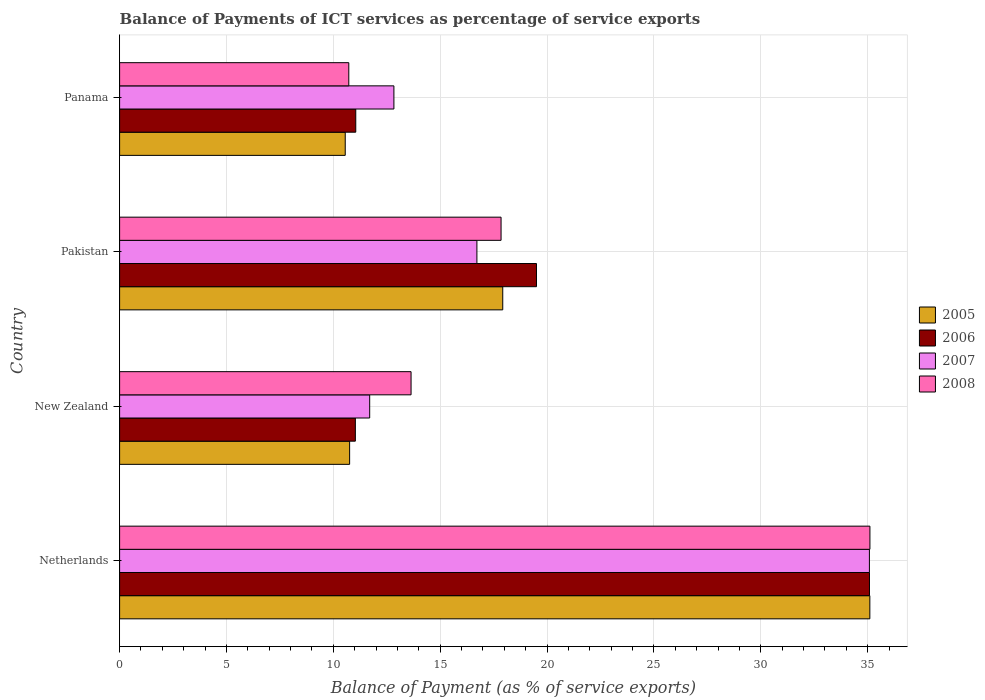How many different coloured bars are there?
Offer a terse response. 4. How many groups of bars are there?
Your answer should be very brief. 4. Are the number of bars per tick equal to the number of legend labels?
Your answer should be compact. Yes. Are the number of bars on each tick of the Y-axis equal?
Your response must be concise. Yes. How many bars are there on the 4th tick from the top?
Offer a terse response. 4. What is the label of the 1st group of bars from the top?
Your answer should be very brief. Panama. What is the balance of payments of ICT services in 2007 in Pakistan?
Keep it short and to the point. 16.72. Across all countries, what is the maximum balance of payments of ICT services in 2008?
Your answer should be compact. 35.11. Across all countries, what is the minimum balance of payments of ICT services in 2007?
Your answer should be compact. 11.7. In which country was the balance of payments of ICT services in 2007 minimum?
Provide a succinct answer. New Zealand. What is the total balance of payments of ICT services in 2008 in the graph?
Offer a very short reply. 77.31. What is the difference between the balance of payments of ICT services in 2006 in New Zealand and that in Panama?
Provide a succinct answer. -0.02. What is the difference between the balance of payments of ICT services in 2005 in Netherlands and the balance of payments of ICT services in 2008 in New Zealand?
Offer a very short reply. 21.47. What is the average balance of payments of ICT services in 2006 per country?
Your response must be concise. 19.17. What is the difference between the balance of payments of ICT services in 2006 and balance of payments of ICT services in 2008 in Pakistan?
Offer a terse response. 1.66. In how many countries, is the balance of payments of ICT services in 2008 greater than 2 %?
Give a very brief answer. 4. What is the ratio of the balance of payments of ICT services in 2008 in Pakistan to that in Panama?
Make the answer very short. 1.66. Is the balance of payments of ICT services in 2005 in Netherlands less than that in Panama?
Provide a succinct answer. No. What is the difference between the highest and the second highest balance of payments of ICT services in 2005?
Your answer should be compact. 17.18. What is the difference between the highest and the lowest balance of payments of ICT services in 2006?
Make the answer very short. 24.05. In how many countries, is the balance of payments of ICT services in 2006 greater than the average balance of payments of ICT services in 2006 taken over all countries?
Provide a short and direct response. 2. Is it the case that in every country, the sum of the balance of payments of ICT services in 2007 and balance of payments of ICT services in 2005 is greater than the sum of balance of payments of ICT services in 2006 and balance of payments of ICT services in 2008?
Give a very brief answer. No. Is it the case that in every country, the sum of the balance of payments of ICT services in 2008 and balance of payments of ICT services in 2007 is greater than the balance of payments of ICT services in 2005?
Your answer should be very brief. Yes. How many bars are there?
Provide a succinct answer. 16. Where does the legend appear in the graph?
Offer a terse response. Center right. What is the title of the graph?
Your response must be concise. Balance of Payments of ICT services as percentage of service exports. What is the label or title of the X-axis?
Offer a very short reply. Balance of Payment (as % of service exports). What is the label or title of the Y-axis?
Ensure brevity in your answer.  Country. What is the Balance of Payment (as % of service exports) of 2005 in Netherlands?
Keep it short and to the point. 35.1. What is the Balance of Payment (as % of service exports) in 2006 in Netherlands?
Your answer should be compact. 35.09. What is the Balance of Payment (as % of service exports) in 2007 in Netherlands?
Your response must be concise. 35.08. What is the Balance of Payment (as % of service exports) in 2008 in Netherlands?
Make the answer very short. 35.11. What is the Balance of Payment (as % of service exports) of 2005 in New Zealand?
Offer a very short reply. 10.76. What is the Balance of Payment (as % of service exports) of 2006 in New Zealand?
Give a very brief answer. 11.03. What is the Balance of Payment (as % of service exports) of 2007 in New Zealand?
Keep it short and to the point. 11.7. What is the Balance of Payment (as % of service exports) of 2008 in New Zealand?
Your response must be concise. 13.64. What is the Balance of Payment (as % of service exports) of 2005 in Pakistan?
Offer a very short reply. 17.93. What is the Balance of Payment (as % of service exports) in 2006 in Pakistan?
Make the answer very short. 19.51. What is the Balance of Payment (as % of service exports) in 2007 in Pakistan?
Ensure brevity in your answer.  16.72. What is the Balance of Payment (as % of service exports) of 2008 in Pakistan?
Provide a succinct answer. 17.85. What is the Balance of Payment (as % of service exports) of 2005 in Panama?
Your answer should be compact. 10.56. What is the Balance of Payment (as % of service exports) of 2006 in Panama?
Your answer should be very brief. 11.05. What is the Balance of Payment (as % of service exports) in 2007 in Panama?
Offer a terse response. 12.83. What is the Balance of Payment (as % of service exports) in 2008 in Panama?
Make the answer very short. 10.72. Across all countries, what is the maximum Balance of Payment (as % of service exports) in 2005?
Provide a succinct answer. 35.1. Across all countries, what is the maximum Balance of Payment (as % of service exports) of 2006?
Your answer should be very brief. 35.09. Across all countries, what is the maximum Balance of Payment (as % of service exports) of 2007?
Provide a short and direct response. 35.08. Across all countries, what is the maximum Balance of Payment (as % of service exports) in 2008?
Offer a very short reply. 35.11. Across all countries, what is the minimum Balance of Payment (as % of service exports) in 2005?
Make the answer very short. 10.56. Across all countries, what is the minimum Balance of Payment (as % of service exports) in 2006?
Your response must be concise. 11.03. Across all countries, what is the minimum Balance of Payment (as % of service exports) of 2007?
Offer a very short reply. 11.7. Across all countries, what is the minimum Balance of Payment (as % of service exports) of 2008?
Offer a terse response. 10.72. What is the total Balance of Payment (as % of service exports) in 2005 in the graph?
Your answer should be very brief. 74.35. What is the total Balance of Payment (as % of service exports) of 2006 in the graph?
Offer a terse response. 76.67. What is the total Balance of Payment (as % of service exports) in 2007 in the graph?
Your response must be concise. 76.33. What is the total Balance of Payment (as % of service exports) in 2008 in the graph?
Provide a short and direct response. 77.31. What is the difference between the Balance of Payment (as % of service exports) in 2005 in Netherlands and that in New Zealand?
Provide a short and direct response. 24.34. What is the difference between the Balance of Payment (as % of service exports) in 2006 in Netherlands and that in New Zealand?
Keep it short and to the point. 24.05. What is the difference between the Balance of Payment (as % of service exports) in 2007 in Netherlands and that in New Zealand?
Your answer should be very brief. 23.38. What is the difference between the Balance of Payment (as % of service exports) in 2008 in Netherlands and that in New Zealand?
Make the answer very short. 21.47. What is the difference between the Balance of Payment (as % of service exports) of 2005 in Netherlands and that in Pakistan?
Your answer should be very brief. 17.18. What is the difference between the Balance of Payment (as % of service exports) in 2006 in Netherlands and that in Pakistan?
Offer a very short reply. 15.58. What is the difference between the Balance of Payment (as % of service exports) of 2007 in Netherlands and that in Pakistan?
Provide a short and direct response. 18.36. What is the difference between the Balance of Payment (as % of service exports) in 2008 in Netherlands and that in Pakistan?
Your answer should be compact. 17.26. What is the difference between the Balance of Payment (as % of service exports) in 2005 in Netherlands and that in Panama?
Make the answer very short. 24.55. What is the difference between the Balance of Payment (as % of service exports) of 2006 in Netherlands and that in Panama?
Provide a short and direct response. 24.04. What is the difference between the Balance of Payment (as % of service exports) in 2007 in Netherlands and that in Panama?
Offer a terse response. 22.25. What is the difference between the Balance of Payment (as % of service exports) of 2008 in Netherlands and that in Panama?
Provide a succinct answer. 24.38. What is the difference between the Balance of Payment (as % of service exports) of 2005 in New Zealand and that in Pakistan?
Provide a short and direct response. -7.16. What is the difference between the Balance of Payment (as % of service exports) in 2006 in New Zealand and that in Pakistan?
Provide a succinct answer. -8.47. What is the difference between the Balance of Payment (as % of service exports) of 2007 in New Zealand and that in Pakistan?
Your response must be concise. -5.02. What is the difference between the Balance of Payment (as % of service exports) of 2008 in New Zealand and that in Pakistan?
Make the answer very short. -4.21. What is the difference between the Balance of Payment (as % of service exports) of 2005 in New Zealand and that in Panama?
Provide a short and direct response. 0.2. What is the difference between the Balance of Payment (as % of service exports) in 2006 in New Zealand and that in Panama?
Make the answer very short. -0.02. What is the difference between the Balance of Payment (as % of service exports) in 2007 in New Zealand and that in Panama?
Provide a short and direct response. -1.13. What is the difference between the Balance of Payment (as % of service exports) of 2008 in New Zealand and that in Panama?
Give a very brief answer. 2.91. What is the difference between the Balance of Payment (as % of service exports) in 2005 in Pakistan and that in Panama?
Offer a very short reply. 7.37. What is the difference between the Balance of Payment (as % of service exports) of 2006 in Pakistan and that in Panama?
Provide a succinct answer. 8.46. What is the difference between the Balance of Payment (as % of service exports) in 2007 in Pakistan and that in Panama?
Make the answer very short. 3.88. What is the difference between the Balance of Payment (as % of service exports) in 2008 in Pakistan and that in Panama?
Your answer should be compact. 7.12. What is the difference between the Balance of Payment (as % of service exports) in 2005 in Netherlands and the Balance of Payment (as % of service exports) in 2006 in New Zealand?
Offer a terse response. 24.07. What is the difference between the Balance of Payment (as % of service exports) in 2005 in Netherlands and the Balance of Payment (as % of service exports) in 2007 in New Zealand?
Your response must be concise. 23.4. What is the difference between the Balance of Payment (as % of service exports) of 2005 in Netherlands and the Balance of Payment (as % of service exports) of 2008 in New Zealand?
Provide a succinct answer. 21.47. What is the difference between the Balance of Payment (as % of service exports) of 2006 in Netherlands and the Balance of Payment (as % of service exports) of 2007 in New Zealand?
Ensure brevity in your answer.  23.38. What is the difference between the Balance of Payment (as % of service exports) in 2006 in Netherlands and the Balance of Payment (as % of service exports) in 2008 in New Zealand?
Give a very brief answer. 21.45. What is the difference between the Balance of Payment (as % of service exports) of 2007 in Netherlands and the Balance of Payment (as % of service exports) of 2008 in New Zealand?
Keep it short and to the point. 21.44. What is the difference between the Balance of Payment (as % of service exports) in 2005 in Netherlands and the Balance of Payment (as % of service exports) in 2006 in Pakistan?
Give a very brief answer. 15.6. What is the difference between the Balance of Payment (as % of service exports) in 2005 in Netherlands and the Balance of Payment (as % of service exports) in 2007 in Pakistan?
Your answer should be very brief. 18.39. What is the difference between the Balance of Payment (as % of service exports) of 2005 in Netherlands and the Balance of Payment (as % of service exports) of 2008 in Pakistan?
Offer a very short reply. 17.25. What is the difference between the Balance of Payment (as % of service exports) in 2006 in Netherlands and the Balance of Payment (as % of service exports) in 2007 in Pakistan?
Provide a short and direct response. 18.37. What is the difference between the Balance of Payment (as % of service exports) of 2006 in Netherlands and the Balance of Payment (as % of service exports) of 2008 in Pakistan?
Offer a terse response. 17.24. What is the difference between the Balance of Payment (as % of service exports) of 2007 in Netherlands and the Balance of Payment (as % of service exports) of 2008 in Pakistan?
Provide a short and direct response. 17.23. What is the difference between the Balance of Payment (as % of service exports) in 2005 in Netherlands and the Balance of Payment (as % of service exports) in 2006 in Panama?
Your answer should be compact. 24.05. What is the difference between the Balance of Payment (as % of service exports) in 2005 in Netherlands and the Balance of Payment (as % of service exports) in 2007 in Panama?
Your answer should be very brief. 22.27. What is the difference between the Balance of Payment (as % of service exports) of 2005 in Netherlands and the Balance of Payment (as % of service exports) of 2008 in Panama?
Your answer should be very brief. 24.38. What is the difference between the Balance of Payment (as % of service exports) of 2006 in Netherlands and the Balance of Payment (as % of service exports) of 2007 in Panama?
Provide a short and direct response. 22.25. What is the difference between the Balance of Payment (as % of service exports) in 2006 in Netherlands and the Balance of Payment (as % of service exports) in 2008 in Panama?
Offer a very short reply. 24.36. What is the difference between the Balance of Payment (as % of service exports) in 2007 in Netherlands and the Balance of Payment (as % of service exports) in 2008 in Panama?
Give a very brief answer. 24.36. What is the difference between the Balance of Payment (as % of service exports) of 2005 in New Zealand and the Balance of Payment (as % of service exports) of 2006 in Pakistan?
Offer a very short reply. -8.74. What is the difference between the Balance of Payment (as % of service exports) of 2005 in New Zealand and the Balance of Payment (as % of service exports) of 2007 in Pakistan?
Keep it short and to the point. -5.96. What is the difference between the Balance of Payment (as % of service exports) of 2005 in New Zealand and the Balance of Payment (as % of service exports) of 2008 in Pakistan?
Make the answer very short. -7.09. What is the difference between the Balance of Payment (as % of service exports) in 2006 in New Zealand and the Balance of Payment (as % of service exports) in 2007 in Pakistan?
Offer a very short reply. -5.69. What is the difference between the Balance of Payment (as % of service exports) of 2006 in New Zealand and the Balance of Payment (as % of service exports) of 2008 in Pakistan?
Offer a very short reply. -6.82. What is the difference between the Balance of Payment (as % of service exports) in 2007 in New Zealand and the Balance of Payment (as % of service exports) in 2008 in Pakistan?
Your answer should be compact. -6.15. What is the difference between the Balance of Payment (as % of service exports) in 2005 in New Zealand and the Balance of Payment (as % of service exports) in 2006 in Panama?
Offer a terse response. -0.29. What is the difference between the Balance of Payment (as % of service exports) in 2005 in New Zealand and the Balance of Payment (as % of service exports) in 2007 in Panama?
Your answer should be compact. -2.07. What is the difference between the Balance of Payment (as % of service exports) of 2005 in New Zealand and the Balance of Payment (as % of service exports) of 2008 in Panama?
Your answer should be compact. 0.04. What is the difference between the Balance of Payment (as % of service exports) of 2006 in New Zealand and the Balance of Payment (as % of service exports) of 2007 in Panama?
Ensure brevity in your answer.  -1.8. What is the difference between the Balance of Payment (as % of service exports) of 2006 in New Zealand and the Balance of Payment (as % of service exports) of 2008 in Panama?
Keep it short and to the point. 0.31. What is the difference between the Balance of Payment (as % of service exports) of 2007 in New Zealand and the Balance of Payment (as % of service exports) of 2008 in Panama?
Your answer should be compact. 0.98. What is the difference between the Balance of Payment (as % of service exports) in 2005 in Pakistan and the Balance of Payment (as % of service exports) in 2006 in Panama?
Your answer should be compact. 6.88. What is the difference between the Balance of Payment (as % of service exports) of 2005 in Pakistan and the Balance of Payment (as % of service exports) of 2007 in Panama?
Offer a terse response. 5.09. What is the difference between the Balance of Payment (as % of service exports) in 2005 in Pakistan and the Balance of Payment (as % of service exports) in 2008 in Panama?
Offer a very short reply. 7.2. What is the difference between the Balance of Payment (as % of service exports) in 2006 in Pakistan and the Balance of Payment (as % of service exports) in 2007 in Panama?
Provide a succinct answer. 6.67. What is the difference between the Balance of Payment (as % of service exports) of 2006 in Pakistan and the Balance of Payment (as % of service exports) of 2008 in Panama?
Keep it short and to the point. 8.78. What is the difference between the Balance of Payment (as % of service exports) of 2007 in Pakistan and the Balance of Payment (as % of service exports) of 2008 in Panama?
Your answer should be very brief. 5.99. What is the average Balance of Payment (as % of service exports) in 2005 per country?
Offer a very short reply. 18.59. What is the average Balance of Payment (as % of service exports) of 2006 per country?
Offer a terse response. 19.17. What is the average Balance of Payment (as % of service exports) in 2007 per country?
Your answer should be compact. 19.08. What is the average Balance of Payment (as % of service exports) of 2008 per country?
Your response must be concise. 19.33. What is the difference between the Balance of Payment (as % of service exports) of 2005 and Balance of Payment (as % of service exports) of 2006 in Netherlands?
Give a very brief answer. 0.02. What is the difference between the Balance of Payment (as % of service exports) in 2005 and Balance of Payment (as % of service exports) in 2007 in Netherlands?
Your response must be concise. 0.02. What is the difference between the Balance of Payment (as % of service exports) in 2005 and Balance of Payment (as % of service exports) in 2008 in Netherlands?
Provide a succinct answer. -0. What is the difference between the Balance of Payment (as % of service exports) in 2006 and Balance of Payment (as % of service exports) in 2007 in Netherlands?
Your response must be concise. 0. What is the difference between the Balance of Payment (as % of service exports) in 2006 and Balance of Payment (as % of service exports) in 2008 in Netherlands?
Keep it short and to the point. -0.02. What is the difference between the Balance of Payment (as % of service exports) in 2007 and Balance of Payment (as % of service exports) in 2008 in Netherlands?
Provide a short and direct response. -0.02. What is the difference between the Balance of Payment (as % of service exports) of 2005 and Balance of Payment (as % of service exports) of 2006 in New Zealand?
Offer a very short reply. -0.27. What is the difference between the Balance of Payment (as % of service exports) of 2005 and Balance of Payment (as % of service exports) of 2007 in New Zealand?
Ensure brevity in your answer.  -0.94. What is the difference between the Balance of Payment (as % of service exports) of 2005 and Balance of Payment (as % of service exports) of 2008 in New Zealand?
Give a very brief answer. -2.87. What is the difference between the Balance of Payment (as % of service exports) of 2006 and Balance of Payment (as % of service exports) of 2007 in New Zealand?
Your answer should be compact. -0.67. What is the difference between the Balance of Payment (as % of service exports) in 2006 and Balance of Payment (as % of service exports) in 2008 in New Zealand?
Your answer should be compact. -2.61. What is the difference between the Balance of Payment (as % of service exports) in 2007 and Balance of Payment (as % of service exports) in 2008 in New Zealand?
Give a very brief answer. -1.94. What is the difference between the Balance of Payment (as % of service exports) in 2005 and Balance of Payment (as % of service exports) in 2006 in Pakistan?
Your answer should be compact. -1.58. What is the difference between the Balance of Payment (as % of service exports) in 2005 and Balance of Payment (as % of service exports) in 2007 in Pakistan?
Ensure brevity in your answer.  1.21. What is the difference between the Balance of Payment (as % of service exports) of 2005 and Balance of Payment (as % of service exports) of 2008 in Pakistan?
Keep it short and to the point. 0.08. What is the difference between the Balance of Payment (as % of service exports) in 2006 and Balance of Payment (as % of service exports) in 2007 in Pakistan?
Give a very brief answer. 2.79. What is the difference between the Balance of Payment (as % of service exports) in 2006 and Balance of Payment (as % of service exports) in 2008 in Pakistan?
Give a very brief answer. 1.66. What is the difference between the Balance of Payment (as % of service exports) in 2007 and Balance of Payment (as % of service exports) in 2008 in Pakistan?
Keep it short and to the point. -1.13. What is the difference between the Balance of Payment (as % of service exports) in 2005 and Balance of Payment (as % of service exports) in 2006 in Panama?
Give a very brief answer. -0.49. What is the difference between the Balance of Payment (as % of service exports) of 2005 and Balance of Payment (as % of service exports) of 2007 in Panama?
Provide a succinct answer. -2.28. What is the difference between the Balance of Payment (as % of service exports) of 2005 and Balance of Payment (as % of service exports) of 2008 in Panama?
Ensure brevity in your answer.  -0.17. What is the difference between the Balance of Payment (as % of service exports) of 2006 and Balance of Payment (as % of service exports) of 2007 in Panama?
Your response must be concise. -1.78. What is the difference between the Balance of Payment (as % of service exports) of 2006 and Balance of Payment (as % of service exports) of 2008 in Panama?
Offer a very short reply. 0.33. What is the difference between the Balance of Payment (as % of service exports) in 2007 and Balance of Payment (as % of service exports) in 2008 in Panama?
Make the answer very short. 2.11. What is the ratio of the Balance of Payment (as % of service exports) of 2005 in Netherlands to that in New Zealand?
Your response must be concise. 3.26. What is the ratio of the Balance of Payment (as % of service exports) of 2006 in Netherlands to that in New Zealand?
Ensure brevity in your answer.  3.18. What is the ratio of the Balance of Payment (as % of service exports) in 2007 in Netherlands to that in New Zealand?
Provide a succinct answer. 3. What is the ratio of the Balance of Payment (as % of service exports) in 2008 in Netherlands to that in New Zealand?
Make the answer very short. 2.57. What is the ratio of the Balance of Payment (as % of service exports) in 2005 in Netherlands to that in Pakistan?
Keep it short and to the point. 1.96. What is the ratio of the Balance of Payment (as % of service exports) in 2006 in Netherlands to that in Pakistan?
Provide a short and direct response. 1.8. What is the ratio of the Balance of Payment (as % of service exports) in 2007 in Netherlands to that in Pakistan?
Your response must be concise. 2.1. What is the ratio of the Balance of Payment (as % of service exports) of 2008 in Netherlands to that in Pakistan?
Give a very brief answer. 1.97. What is the ratio of the Balance of Payment (as % of service exports) in 2005 in Netherlands to that in Panama?
Make the answer very short. 3.33. What is the ratio of the Balance of Payment (as % of service exports) of 2006 in Netherlands to that in Panama?
Your answer should be very brief. 3.18. What is the ratio of the Balance of Payment (as % of service exports) in 2007 in Netherlands to that in Panama?
Your response must be concise. 2.73. What is the ratio of the Balance of Payment (as % of service exports) of 2008 in Netherlands to that in Panama?
Offer a very short reply. 3.27. What is the ratio of the Balance of Payment (as % of service exports) of 2005 in New Zealand to that in Pakistan?
Provide a succinct answer. 0.6. What is the ratio of the Balance of Payment (as % of service exports) of 2006 in New Zealand to that in Pakistan?
Give a very brief answer. 0.57. What is the ratio of the Balance of Payment (as % of service exports) in 2007 in New Zealand to that in Pakistan?
Provide a succinct answer. 0.7. What is the ratio of the Balance of Payment (as % of service exports) in 2008 in New Zealand to that in Pakistan?
Your answer should be very brief. 0.76. What is the ratio of the Balance of Payment (as % of service exports) in 2005 in New Zealand to that in Panama?
Provide a short and direct response. 1.02. What is the ratio of the Balance of Payment (as % of service exports) of 2006 in New Zealand to that in Panama?
Your response must be concise. 1. What is the ratio of the Balance of Payment (as % of service exports) in 2007 in New Zealand to that in Panama?
Keep it short and to the point. 0.91. What is the ratio of the Balance of Payment (as % of service exports) of 2008 in New Zealand to that in Panama?
Offer a very short reply. 1.27. What is the ratio of the Balance of Payment (as % of service exports) of 2005 in Pakistan to that in Panama?
Provide a short and direct response. 1.7. What is the ratio of the Balance of Payment (as % of service exports) of 2006 in Pakistan to that in Panama?
Offer a very short reply. 1.77. What is the ratio of the Balance of Payment (as % of service exports) of 2007 in Pakistan to that in Panama?
Keep it short and to the point. 1.3. What is the ratio of the Balance of Payment (as % of service exports) of 2008 in Pakistan to that in Panama?
Give a very brief answer. 1.66. What is the difference between the highest and the second highest Balance of Payment (as % of service exports) in 2005?
Offer a very short reply. 17.18. What is the difference between the highest and the second highest Balance of Payment (as % of service exports) in 2006?
Offer a terse response. 15.58. What is the difference between the highest and the second highest Balance of Payment (as % of service exports) in 2007?
Provide a succinct answer. 18.36. What is the difference between the highest and the second highest Balance of Payment (as % of service exports) in 2008?
Your answer should be very brief. 17.26. What is the difference between the highest and the lowest Balance of Payment (as % of service exports) in 2005?
Make the answer very short. 24.55. What is the difference between the highest and the lowest Balance of Payment (as % of service exports) of 2006?
Keep it short and to the point. 24.05. What is the difference between the highest and the lowest Balance of Payment (as % of service exports) of 2007?
Your response must be concise. 23.38. What is the difference between the highest and the lowest Balance of Payment (as % of service exports) in 2008?
Make the answer very short. 24.38. 